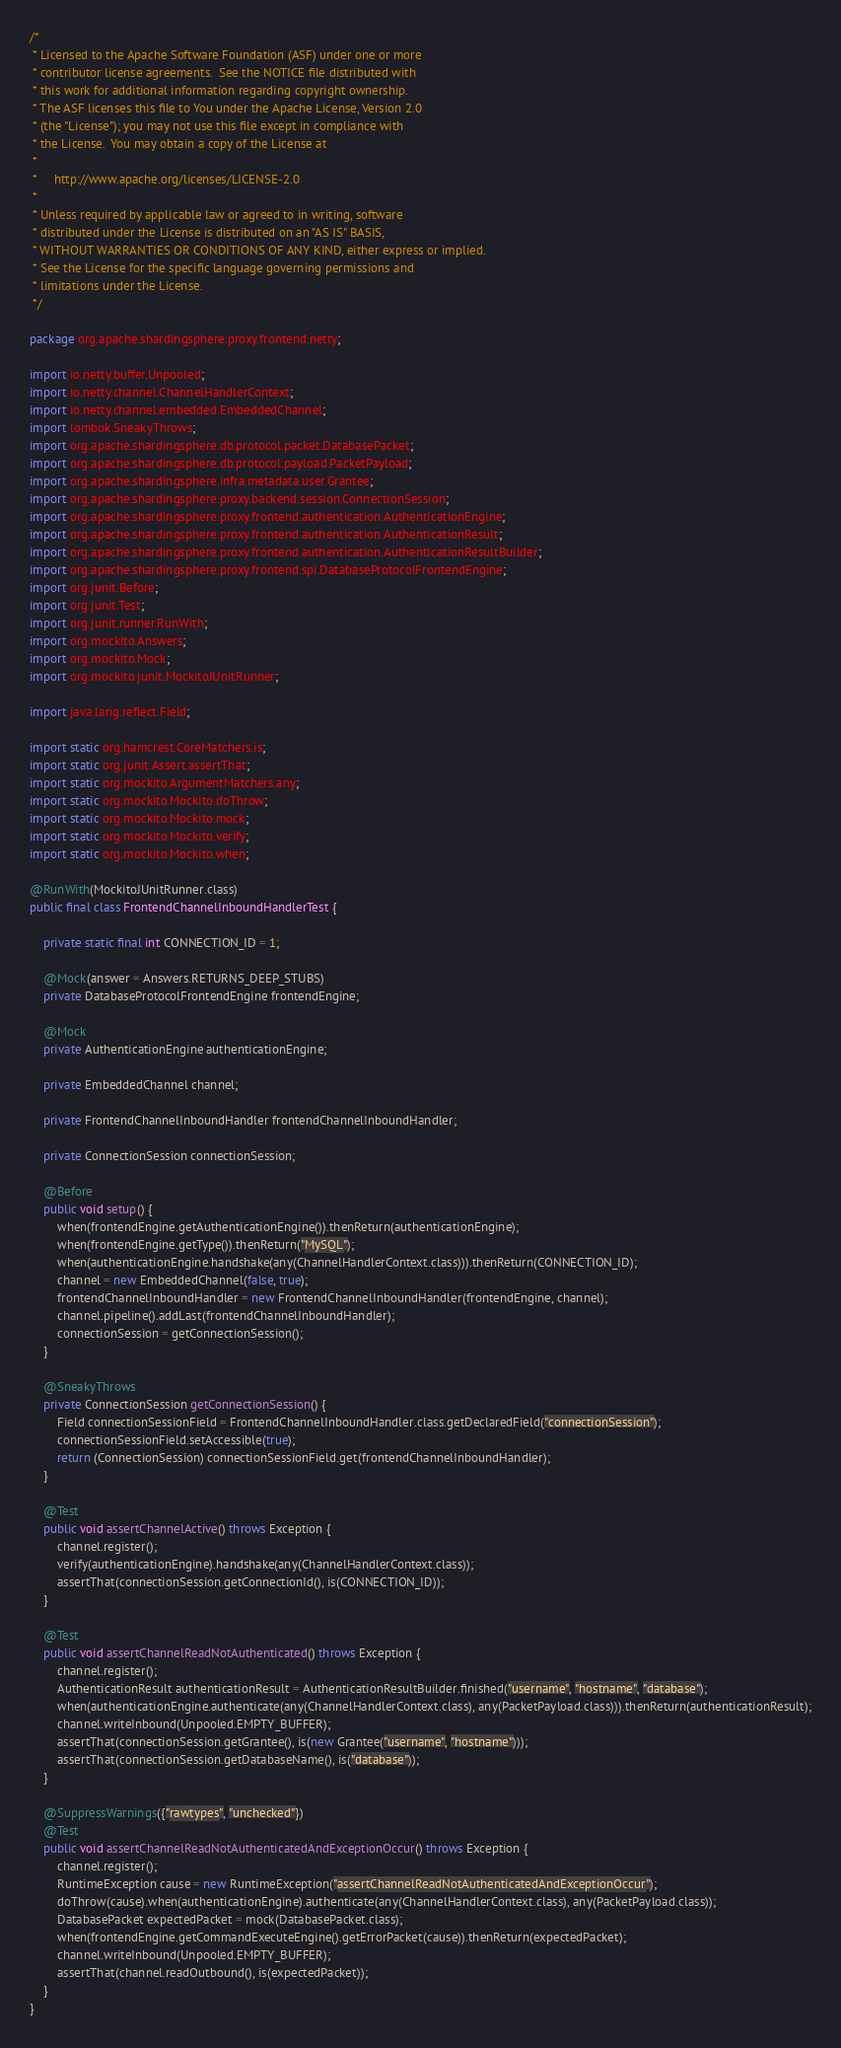<code> <loc_0><loc_0><loc_500><loc_500><_Java_>/*
 * Licensed to the Apache Software Foundation (ASF) under one or more
 * contributor license agreements.  See the NOTICE file distributed with
 * this work for additional information regarding copyright ownership.
 * The ASF licenses this file to You under the Apache License, Version 2.0
 * (the "License"); you may not use this file except in compliance with
 * the License.  You may obtain a copy of the License at
 *
 *     http://www.apache.org/licenses/LICENSE-2.0
 *
 * Unless required by applicable law or agreed to in writing, software
 * distributed under the License is distributed on an "AS IS" BASIS,
 * WITHOUT WARRANTIES OR CONDITIONS OF ANY KIND, either express or implied.
 * See the License for the specific language governing permissions and
 * limitations under the License.
 */

package org.apache.shardingsphere.proxy.frontend.netty;

import io.netty.buffer.Unpooled;
import io.netty.channel.ChannelHandlerContext;
import io.netty.channel.embedded.EmbeddedChannel;
import lombok.SneakyThrows;
import org.apache.shardingsphere.db.protocol.packet.DatabasePacket;
import org.apache.shardingsphere.db.protocol.payload.PacketPayload;
import org.apache.shardingsphere.infra.metadata.user.Grantee;
import org.apache.shardingsphere.proxy.backend.session.ConnectionSession;
import org.apache.shardingsphere.proxy.frontend.authentication.AuthenticationEngine;
import org.apache.shardingsphere.proxy.frontend.authentication.AuthenticationResult;
import org.apache.shardingsphere.proxy.frontend.authentication.AuthenticationResultBuilder;
import org.apache.shardingsphere.proxy.frontend.spi.DatabaseProtocolFrontendEngine;
import org.junit.Before;
import org.junit.Test;
import org.junit.runner.RunWith;
import org.mockito.Answers;
import org.mockito.Mock;
import org.mockito.junit.MockitoJUnitRunner;

import java.lang.reflect.Field;

import static org.hamcrest.CoreMatchers.is;
import static org.junit.Assert.assertThat;
import static org.mockito.ArgumentMatchers.any;
import static org.mockito.Mockito.doThrow;
import static org.mockito.Mockito.mock;
import static org.mockito.Mockito.verify;
import static org.mockito.Mockito.when;

@RunWith(MockitoJUnitRunner.class)
public final class FrontendChannelInboundHandlerTest {
    
    private static final int CONNECTION_ID = 1;
    
    @Mock(answer = Answers.RETURNS_DEEP_STUBS)
    private DatabaseProtocolFrontendEngine frontendEngine;
    
    @Mock
    private AuthenticationEngine authenticationEngine;
    
    private EmbeddedChannel channel;
    
    private FrontendChannelInboundHandler frontendChannelInboundHandler;
    
    private ConnectionSession connectionSession;
    
    @Before
    public void setup() {
        when(frontendEngine.getAuthenticationEngine()).thenReturn(authenticationEngine);
        when(frontendEngine.getType()).thenReturn("MySQL");
        when(authenticationEngine.handshake(any(ChannelHandlerContext.class))).thenReturn(CONNECTION_ID);
        channel = new EmbeddedChannel(false, true);
        frontendChannelInboundHandler = new FrontendChannelInboundHandler(frontendEngine, channel);
        channel.pipeline().addLast(frontendChannelInboundHandler);
        connectionSession = getConnectionSession();
    }
    
    @SneakyThrows
    private ConnectionSession getConnectionSession() {
        Field connectionSessionField = FrontendChannelInboundHandler.class.getDeclaredField("connectionSession");
        connectionSessionField.setAccessible(true);
        return (ConnectionSession) connectionSessionField.get(frontendChannelInboundHandler);
    }
    
    @Test
    public void assertChannelActive() throws Exception {
        channel.register();
        verify(authenticationEngine).handshake(any(ChannelHandlerContext.class));
        assertThat(connectionSession.getConnectionId(), is(CONNECTION_ID));
    }
    
    @Test
    public void assertChannelReadNotAuthenticated() throws Exception {
        channel.register();
        AuthenticationResult authenticationResult = AuthenticationResultBuilder.finished("username", "hostname", "database");
        when(authenticationEngine.authenticate(any(ChannelHandlerContext.class), any(PacketPayload.class))).thenReturn(authenticationResult);
        channel.writeInbound(Unpooled.EMPTY_BUFFER);
        assertThat(connectionSession.getGrantee(), is(new Grantee("username", "hostname")));
        assertThat(connectionSession.getDatabaseName(), is("database"));
    }
    
    @SuppressWarnings({"rawtypes", "unchecked"})
    @Test
    public void assertChannelReadNotAuthenticatedAndExceptionOccur() throws Exception {
        channel.register();
        RuntimeException cause = new RuntimeException("assertChannelReadNotAuthenticatedAndExceptionOccur");
        doThrow(cause).when(authenticationEngine).authenticate(any(ChannelHandlerContext.class), any(PacketPayload.class));
        DatabasePacket expectedPacket = mock(DatabasePacket.class);
        when(frontendEngine.getCommandExecuteEngine().getErrorPacket(cause)).thenReturn(expectedPacket);
        channel.writeInbound(Unpooled.EMPTY_BUFFER);
        assertThat(channel.readOutbound(), is(expectedPacket));
    }
}
</code> 